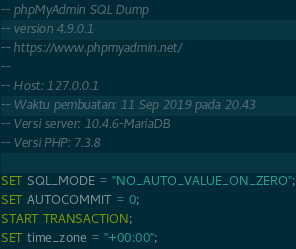Convert code to text. <code><loc_0><loc_0><loc_500><loc_500><_SQL_>-- phpMyAdmin SQL Dump
-- version 4.9.0.1
-- https://www.phpmyadmin.net/
--
-- Host: 127.0.0.1
-- Waktu pembuatan: 11 Sep 2019 pada 20.43
-- Versi server: 10.4.6-MariaDB
-- Versi PHP: 7.3.8

SET SQL_MODE = "NO_AUTO_VALUE_ON_ZERO";
SET AUTOCOMMIT = 0;
START TRANSACTION;
SET time_zone = "+00:00";

</code> 